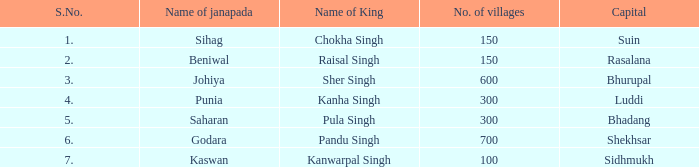On average, how many villages in punia have the name janapada? 300.0. 